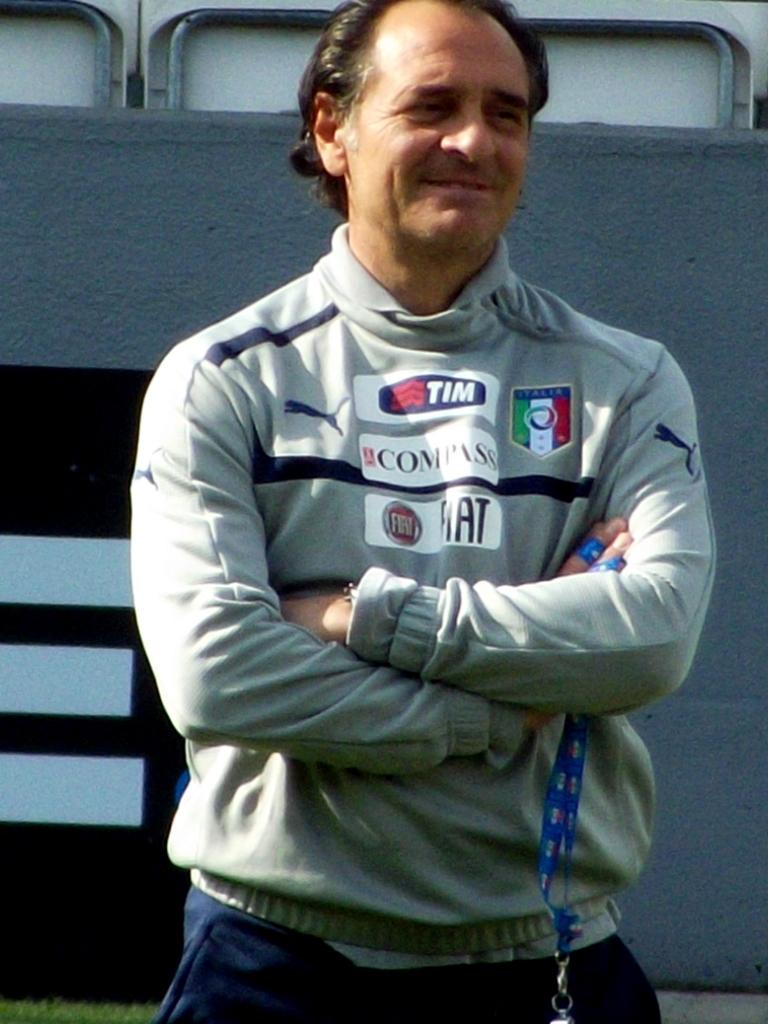<image>
Summarize the visual content of the image. A man wears a sweatshirt with many logos and names, the bottom logo is FIAT. 